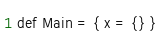Convert code to text. <code><loc_0><loc_0><loc_500><loc_500><_SQL_>
def Main = { x = {} }
</code> 